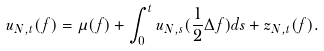<formula> <loc_0><loc_0><loc_500><loc_500>u _ { N , t } ( f ) = \mu ( f ) + \int ^ { t } _ { 0 } u _ { N , s } ( \frac { 1 } { 2 } \Delta f ) d s + z _ { N , t } ( f ) .</formula> 